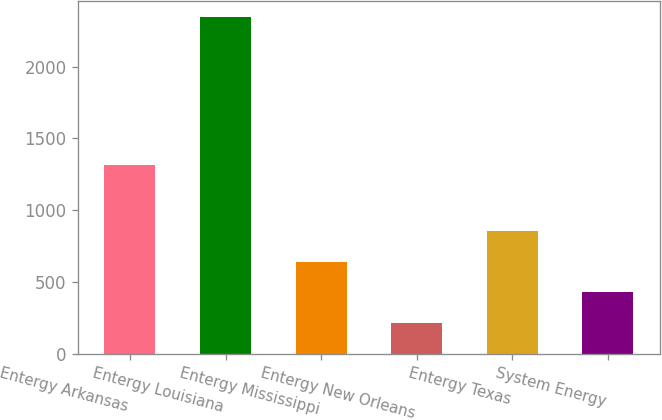<chart> <loc_0><loc_0><loc_500><loc_500><bar_chart><fcel>Entergy Arkansas<fcel>Entergy Louisiana<fcel>Entergy Mississippi<fcel>Entergy New Orleans<fcel>Entergy Texas<fcel>System Energy<nl><fcel>1313<fcel>2343<fcel>639.8<fcel>214<fcel>852.7<fcel>426.9<nl></chart> 